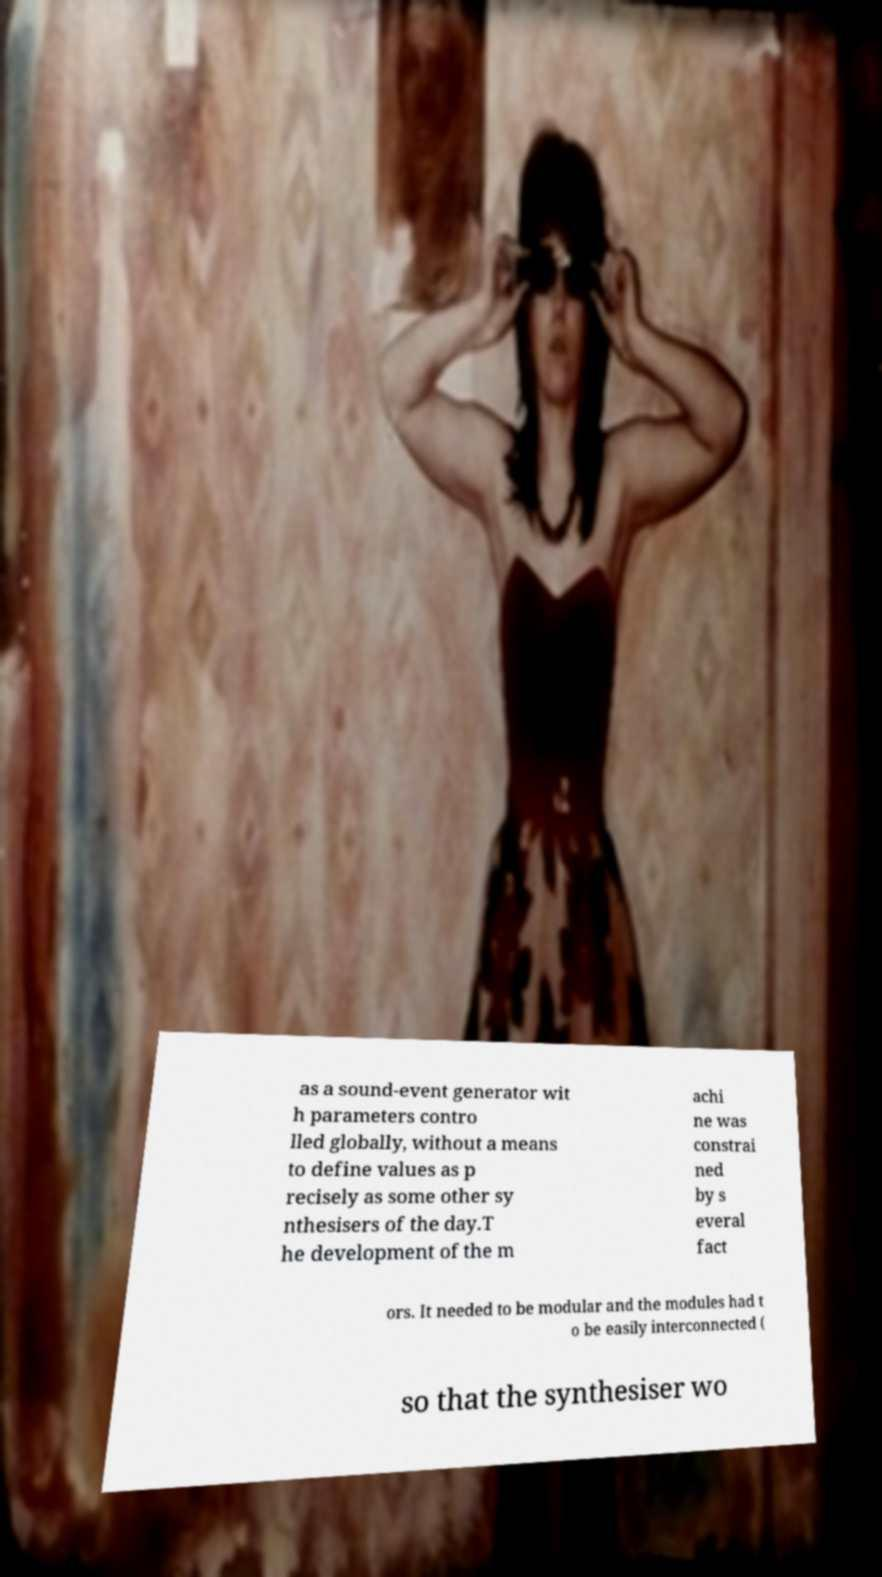Could you assist in decoding the text presented in this image and type it out clearly? as a sound-event generator wit h parameters contro lled globally, without a means to define values as p recisely as some other sy nthesisers of the day.T he development of the m achi ne was constrai ned by s everal fact ors. It needed to be modular and the modules had t o be easily interconnected ( so that the synthesiser wo 